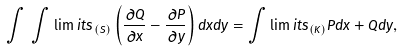Convert formula to latex. <formula><loc_0><loc_0><loc_500><loc_500>\int \, \int \lim i t s _ { \, ( S ) } \left ( \frac { \partial Q } { \partial x } - \frac { \partial P } { \partial y } \right ) d x d y = \int \lim i t s _ { ( K ) } P d x + Q d y ,</formula> 